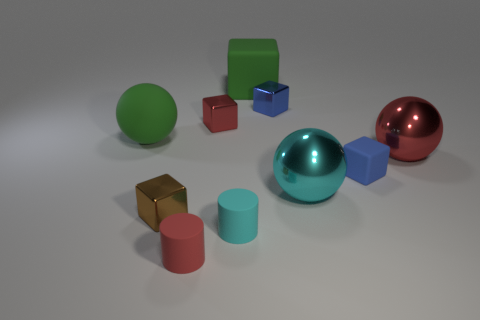Subtract all small red cubes. How many cubes are left? 4 Subtract 3 blocks. How many blocks are left? 2 Subtract all red cubes. How many cubes are left? 4 Subtract all cyan blocks. Subtract all red spheres. How many blocks are left? 5 Subtract all cylinders. How many objects are left? 8 Subtract 1 red cubes. How many objects are left? 9 Subtract all tiny blue shiny things. Subtract all large balls. How many objects are left? 6 Add 4 small red blocks. How many small red blocks are left? 5 Add 5 big brown spheres. How many big brown spheres exist? 5 